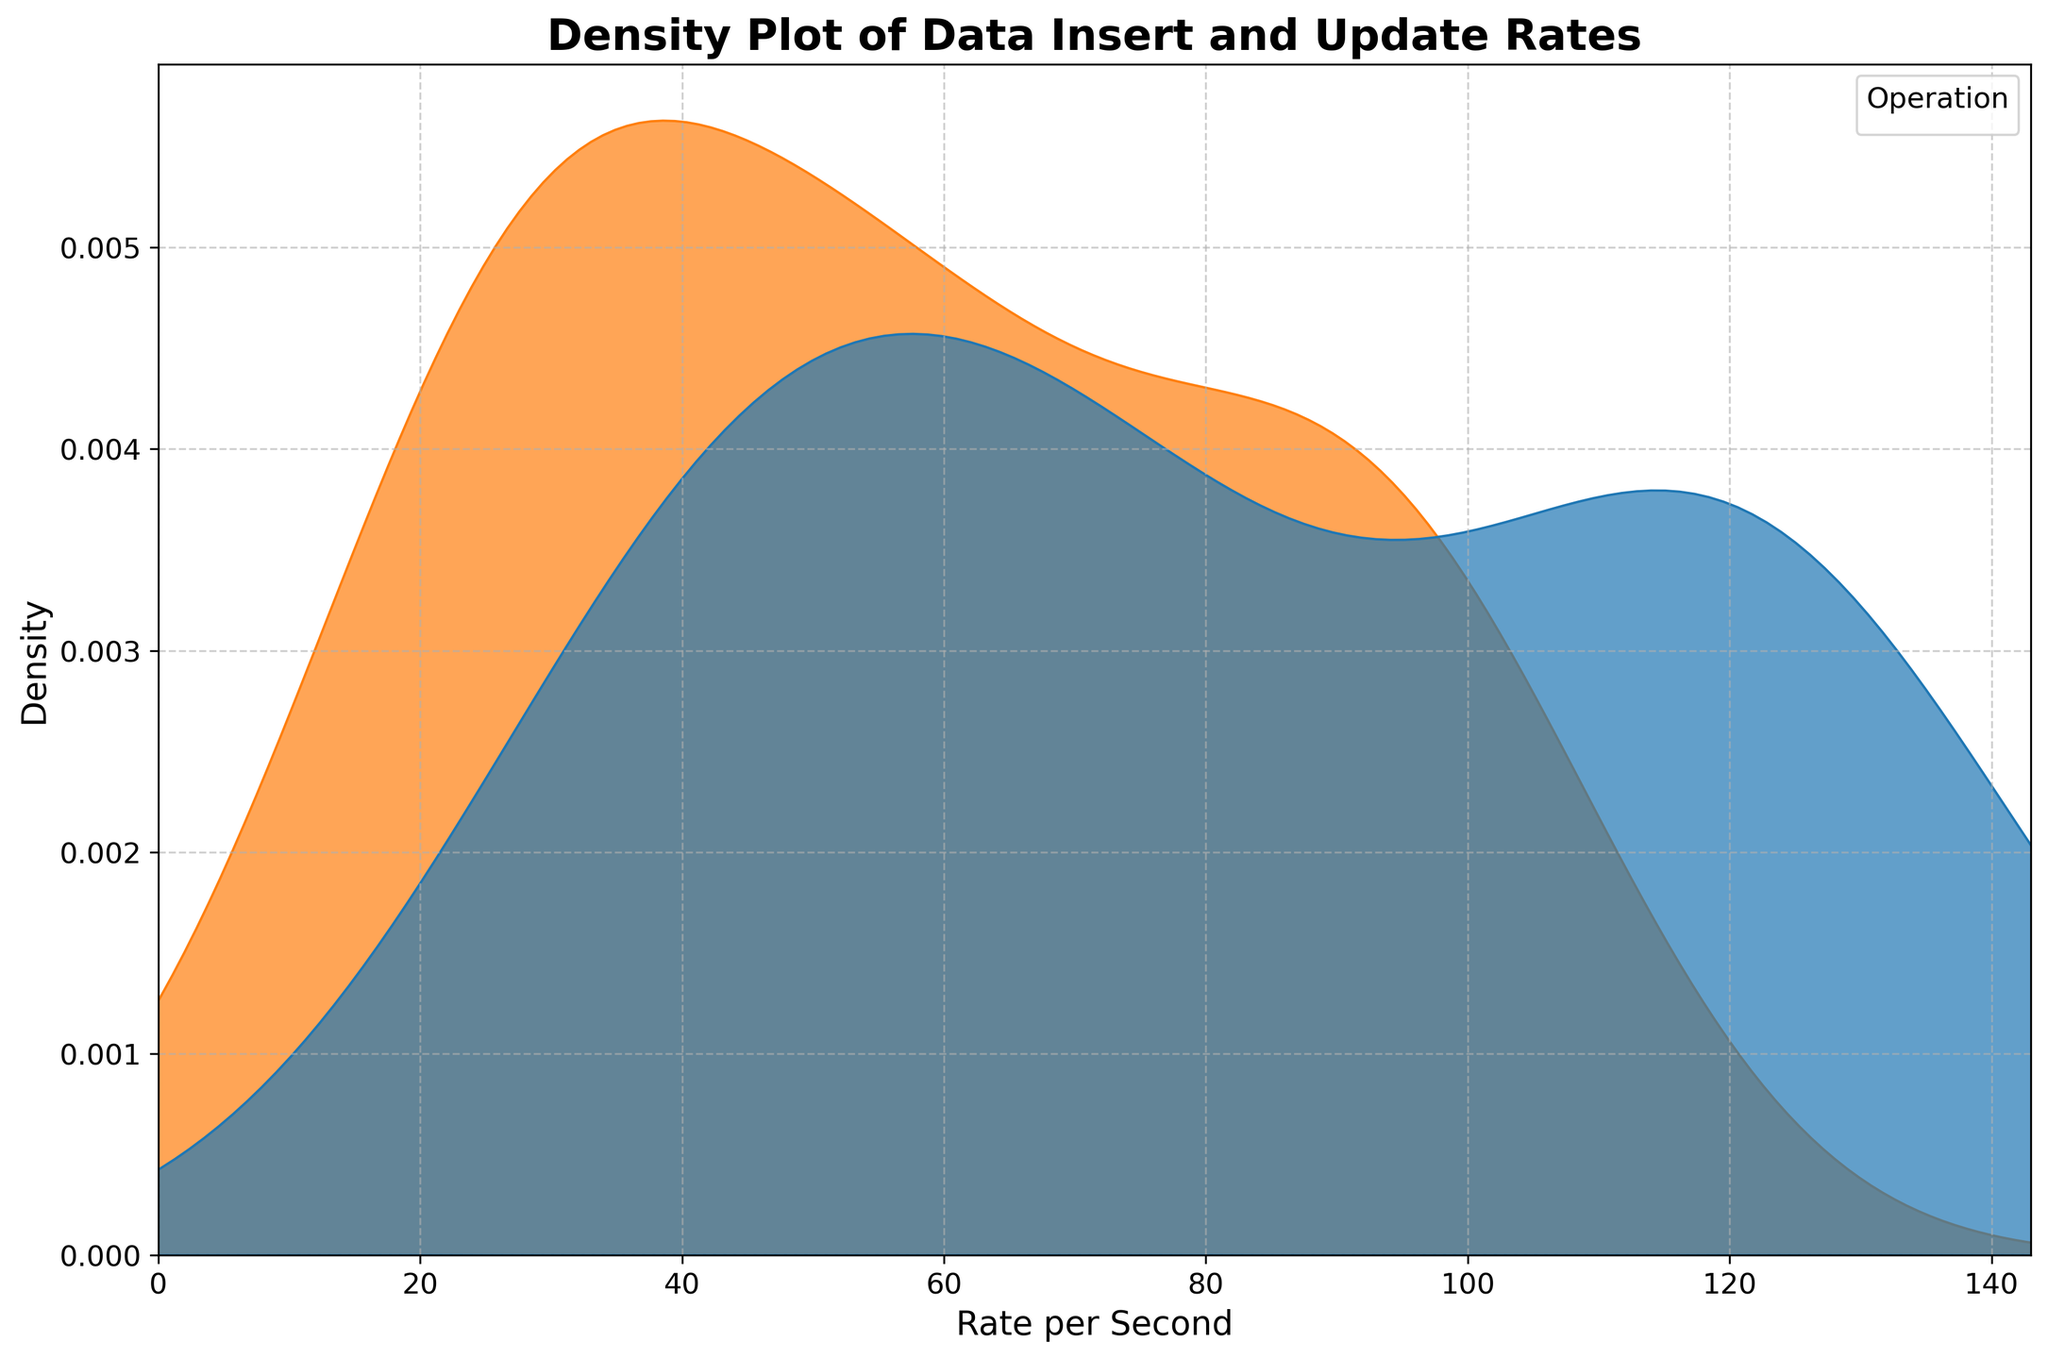What is the title of the plot? The title of the plot is shown at the top center of the figure and reads 'Density Plot of Data Insert and Update Rates'.
Answer: Density Plot of Data Insert and Update Rates What is the x-axis label of the plot? The x-axis label is placed along the bottom horizontal axis of the plot and reads 'Rate per Second'.
Answer: Rate per Second Which operation shows a higher peak density on the plot? By examining the peak heights of the density curves, the 'insert' operation has higher peaks compared to the 'update' operation, implying higher density.
Answer: insert What is the general shape of the density curves for the insert and update operations? The density curves are generally smooth with peaks that vary in height along the x-axis, showing the distribution of the rates per second. Both curves exhibit multi-modality with peaks at various points along the x-axis.
Answer: smooth with multiple peaks Between 50 and 100 rate per second, which operation has a wider density curve? Observing the spread of the density curves between the 50 and 100 unit marks on the x-axis, the 'insert' operation's curve appears to have a wider spread compared to the 'update' operation.
Answer: insert What is the maximum rate per second value present on the x-axis? The x-axis is extended to a maximum value slightly beyond the highest data rate to provide sufficient space, which can be seen around 143 (130 * 1.1 based on the data constraint in the code).
Answer: 143 Which operation demonstrates a higher density at around 80 rate per second? By examining the density curves around the 80 rate per second mark, the 'insert' operation demonstrates a higher density.
Answer: insert Can you determine which operation shows more varied rates of occurrence? Based on the broader spread and multiple peaks in the 'insert' curve, it indicates that the 'insert' operation shows more varied rates of occurrence compared to the 'update' operation.
Answer: insert 